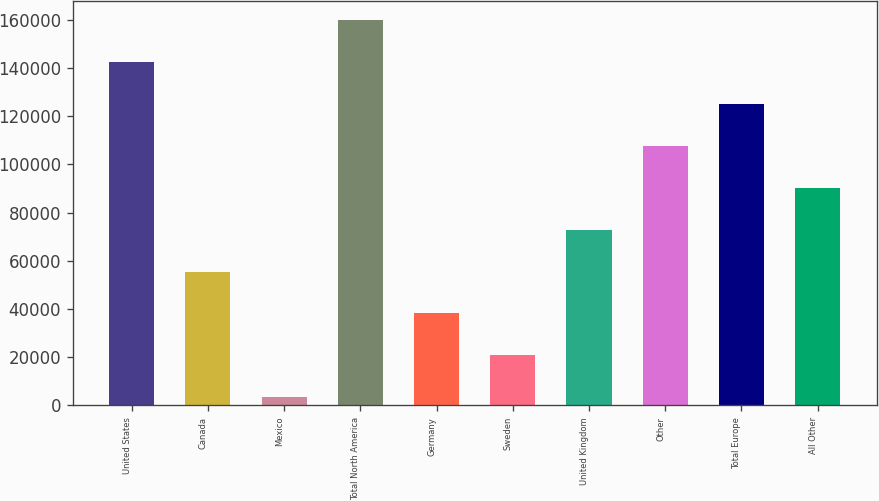Convert chart. <chart><loc_0><loc_0><loc_500><loc_500><bar_chart><fcel>United States<fcel>Canada<fcel>Mexico<fcel>Total North America<fcel>Germany<fcel>Sweden<fcel>United Kingdom<fcel>Other<fcel>Total Europe<fcel>All Other<nl><fcel>142351<fcel>55506<fcel>3399<fcel>159720<fcel>38137<fcel>20768<fcel>72875<fcel>107613<fcel>124982<fcel>90244<nl></chart> 